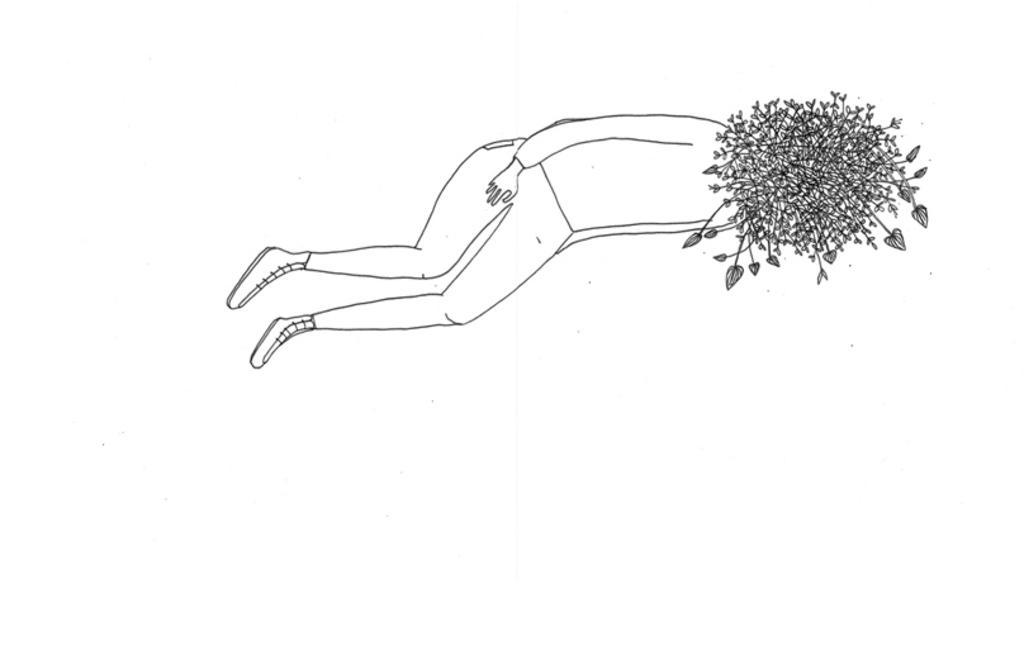How would you summarize this image in a sentence or two? This picture is the sketch of the person and the person is lying on the floor. In the background, it is white in color. 